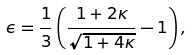Convert formula to latex. <formula><loc_0><loc_0><loc_500><loc_500>\epsilon = \frac { 1 } { 3 } \left ( \frac { 1 + 2 \kappa } { \sqrt { 1 + 4 \kappa } } - 1 \right ) ,</formula> 